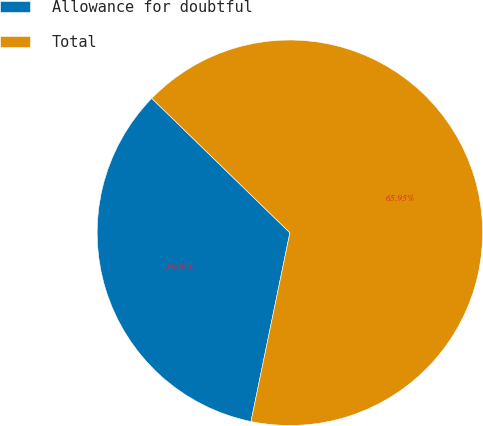Convert chart to OTSL. <chart><loc_0><loc_0><loc_500><loc_500><pie_chart><fcel>Allowance for doubtful<fcel>Total<nl><fcel>34.05%<fcel>65.95%<nl></chart> 